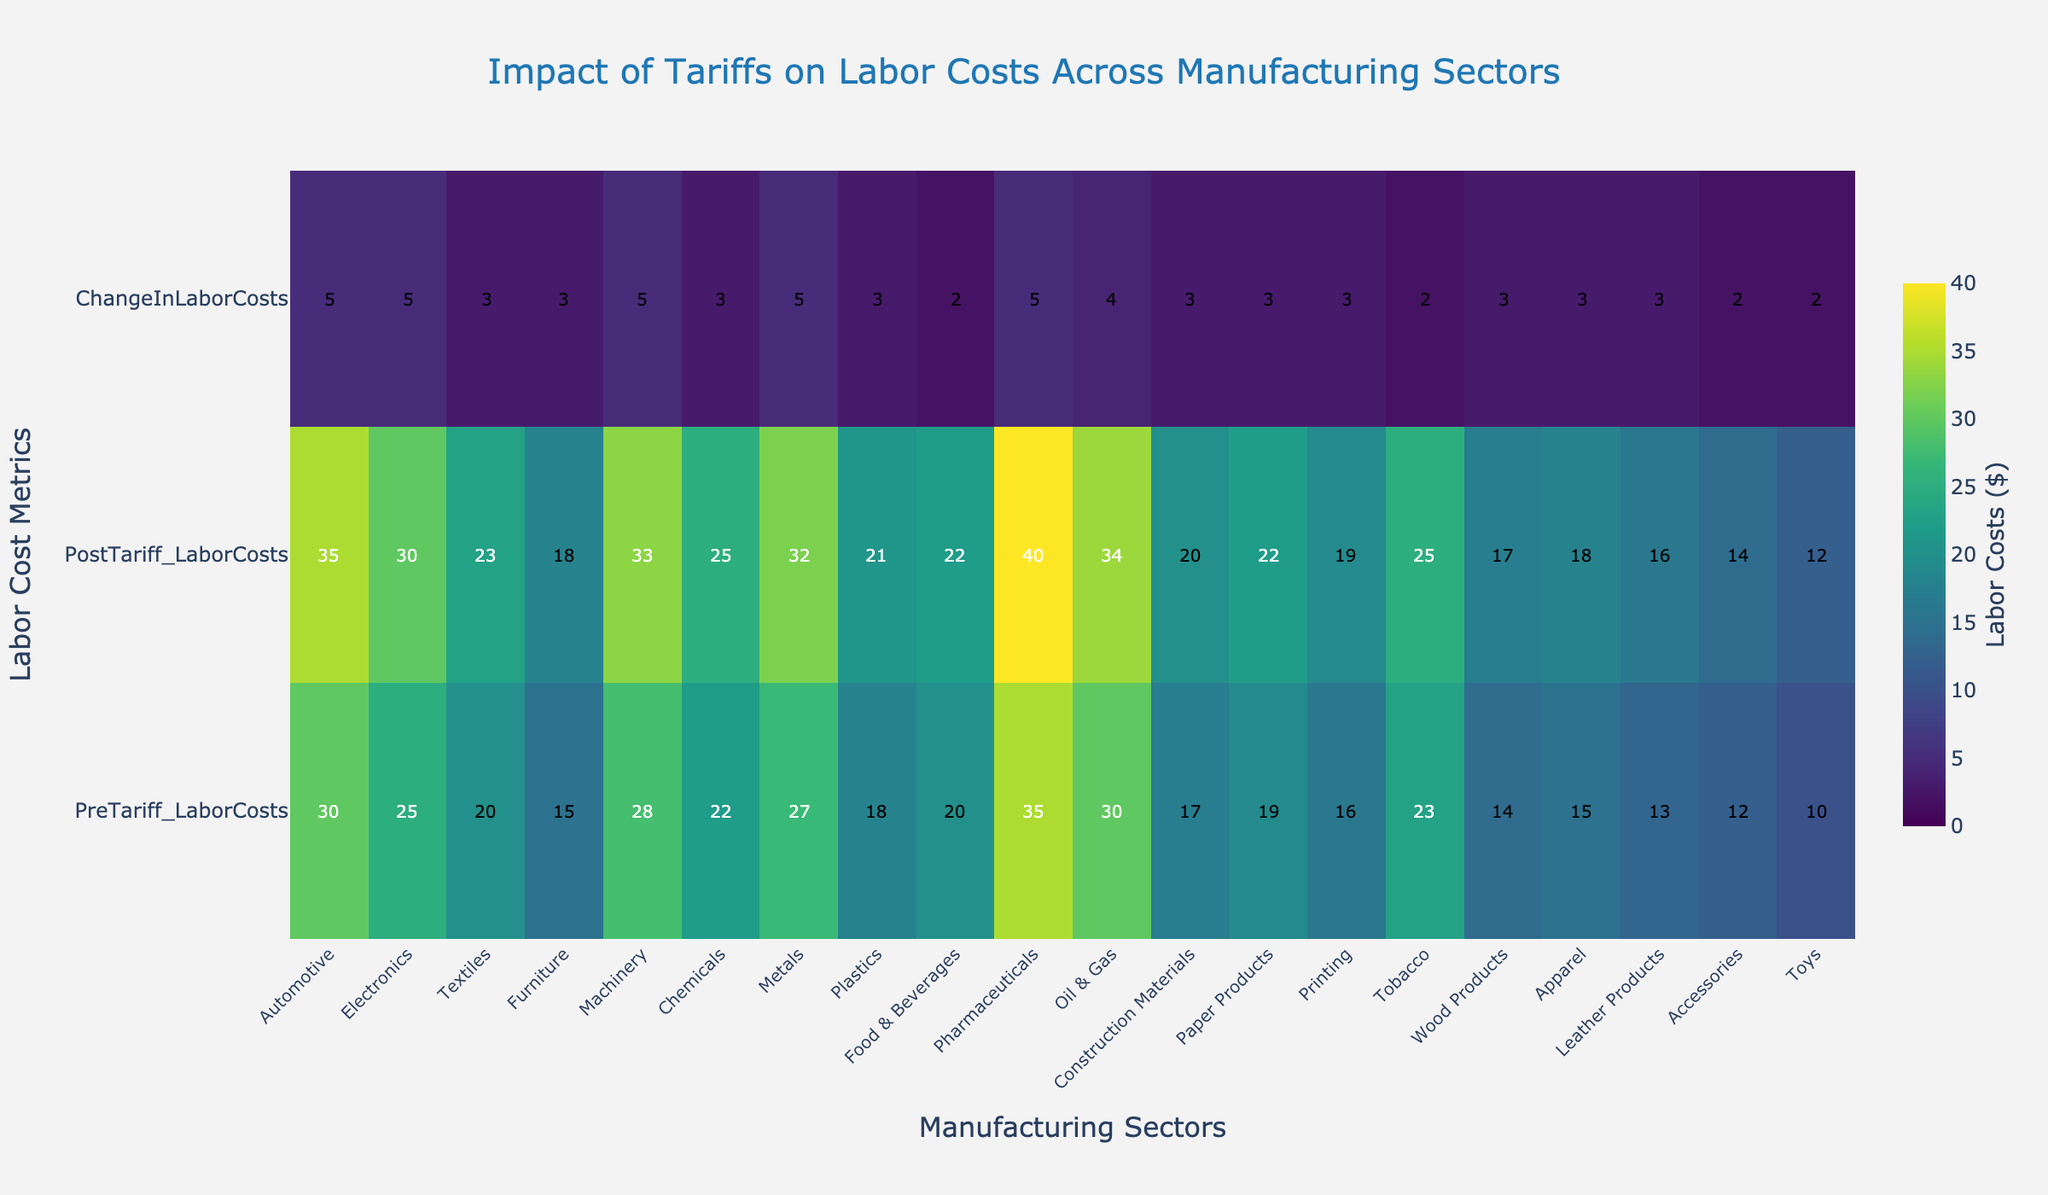What's the title of the heatmap? The title is displayed at the top center of the heatmap. It reads 'Impact of Tariffs on Labor Costs Across Manufacturing Sectors'.
Answer: Impact of Tariffs on Labor Costs Across Manufacturing Sectors Which sector has the highest PreTariff labor costs? Look at the 'PreTariff_LaborCosts' row and identify the sector with the highest value. It is Pharmaceuticals with a value of 35.
Answer: Pharmaceuticals What is the average ChangeInLaborCosts across all sectors? Sum the values in the 'ChangeInLaborCosts' row and divide by the number of sectors (20). The sum is 70, so the average is 70/20 = 3.5.
Answer: 3.5 Which sector experienced the smallest increase in labor costs after tariffs? Locate the sector with the lowest value in the 'ChangeInLaborCosts' row. It is Toys with a value of 2.
Answer: Toys Compare the labor costs for the Electronics sector before and after tariffs. Find 'Electronics' in the x-axis labels, then compare the values in 'PreTariff_LaborCosts' (25) and 'PostTariff_LaborCosts' (30). The difference is 30 - 25 = 5.
Answer: 5 Which sectors saw a 5-unit increase in labor costs due to tariffs? In the 'ChangeInLaborCosts' row, identify sectors with a value of 5. These sectors are Automotive, Electronics, Machinery, Metals, and Pharmaceuticals.
Answer: Automotive, Electronics, Machinery, Metals, Pharmaceuticals What is the combined labor cost for the Construction Materials sector before and after tariffs? Locate 'Construction Materials' on the x-axis. Sum the 'PreTariff_LaborCosts' (17) and 'PostTariff_LaborCosts' (20). The combined cost is 17 + 20 = 37.
Answer: 37 Which sector had a higher PostTariff labor cost: Chemicals or Printing? Compare 'PostTariff_LaborCosts' for both sectors. Chemicals has 25 and Printing has 19. Therefore, Chemicals has a higher value.
Answer: Chemicals What is the total labor cost change for sectors with an initial PreTariff labor cost above 25? Identify sectors with PreTariff costs > 25: Automotive (30), Electronics (25), Machinery (28), Metals (27), Pharmaceuticals (35), Oil & Gas (30). Sum their ChangeInLaborCosts: 5 (Automotive) + 5 (Electronics) + 5 (Machinery) + 5 (Metals) + 5 (Pharmaceuticals) + 4 (Oil & Gas) = 29.
Answer: 29 